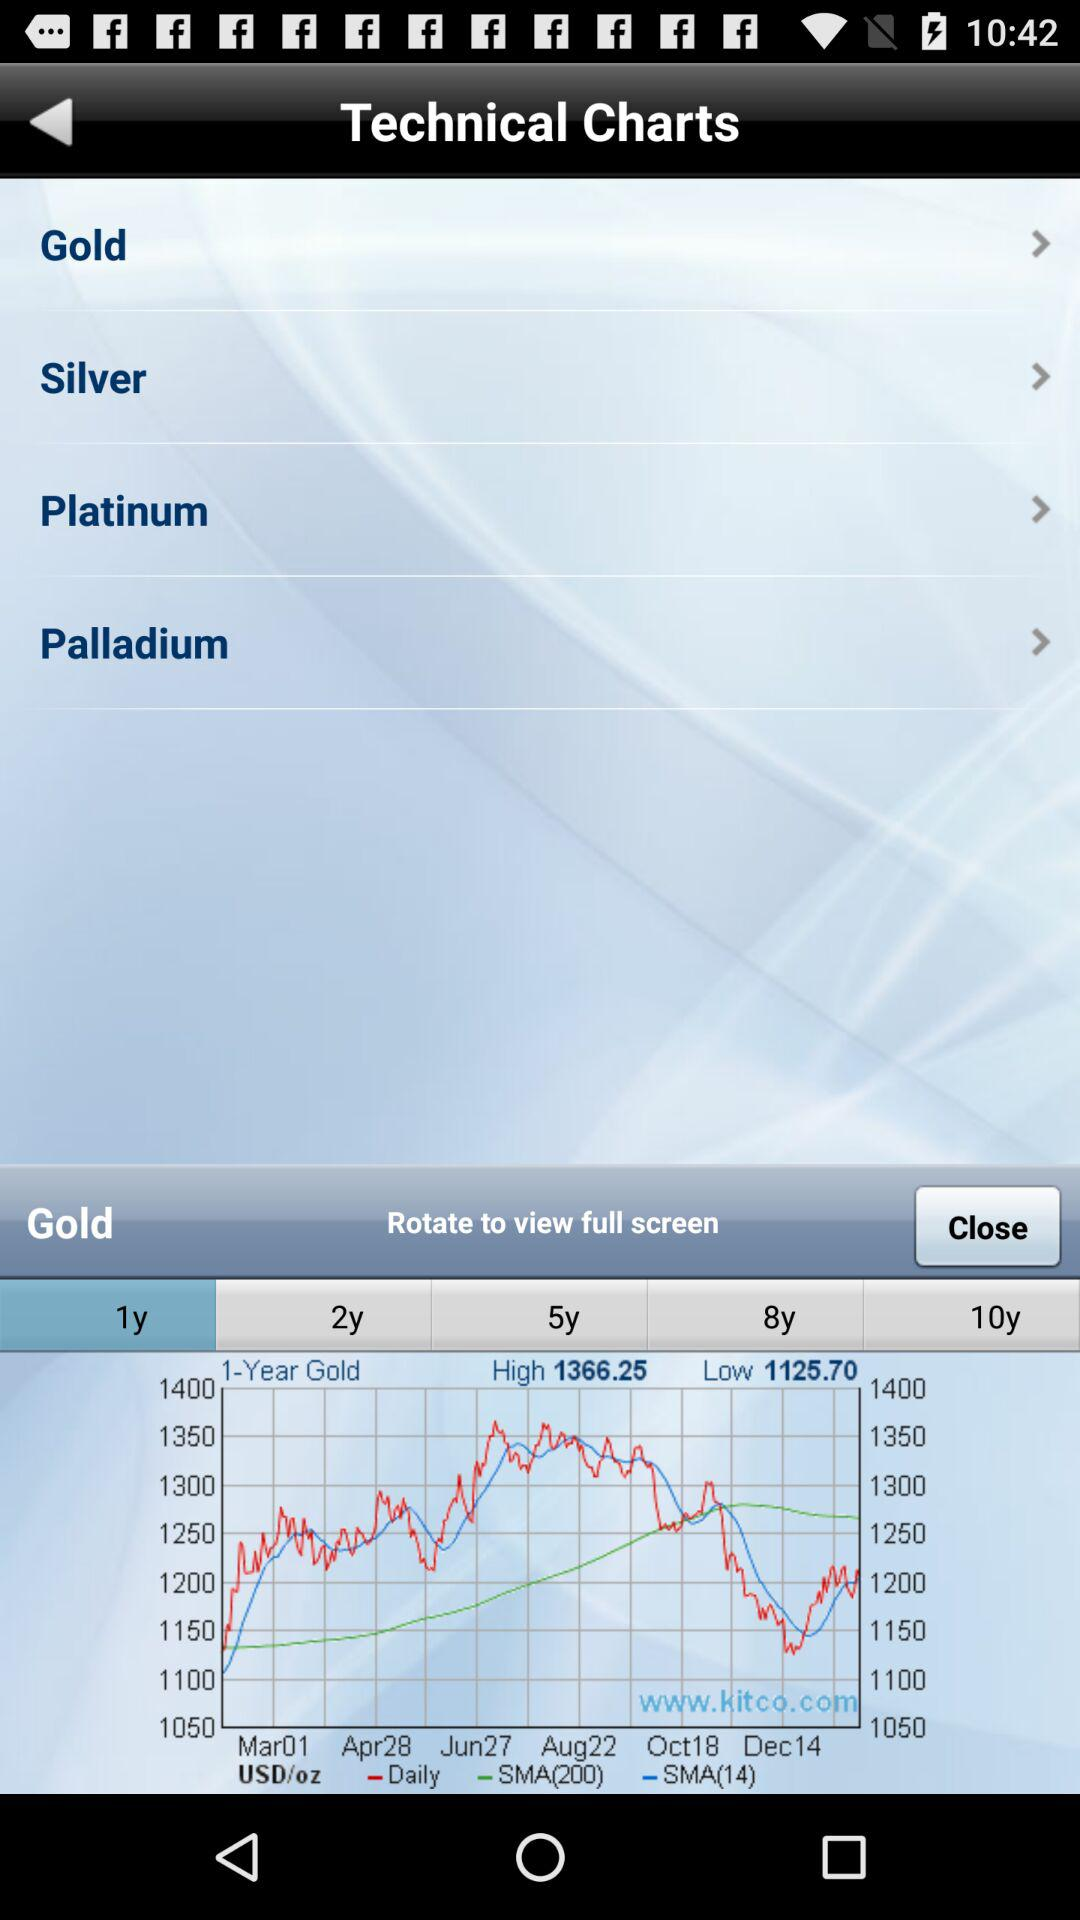What is the high value given on the screen? The high value is 1366.25. 